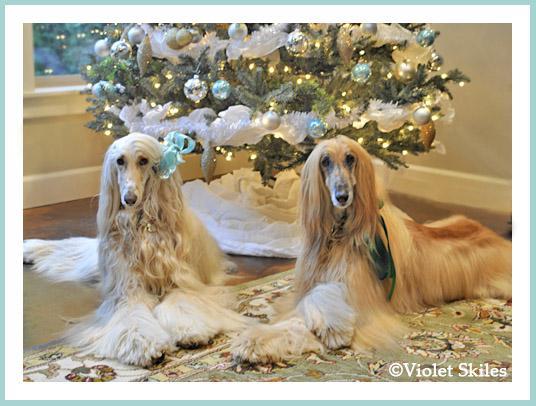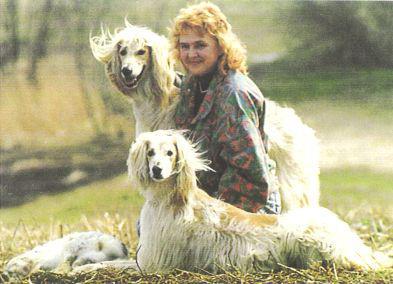The first image is the image on the left, the second image is the image on the right. Evaluate the accuracy of this statement regarding the images: "There are 3 dogs.". Is it true? Answer yes or no. No. The first image is the image on the left, the second image is the image on the right. Evaluate the accuracy of this statement regarding the images: "A total of three afghan hounds are shown, including one hound that stands alone in an image and gazes toward the camera, and a reclining hound that is on the left of another dog in the other image.". Is it true? Answer yes or no. No. 